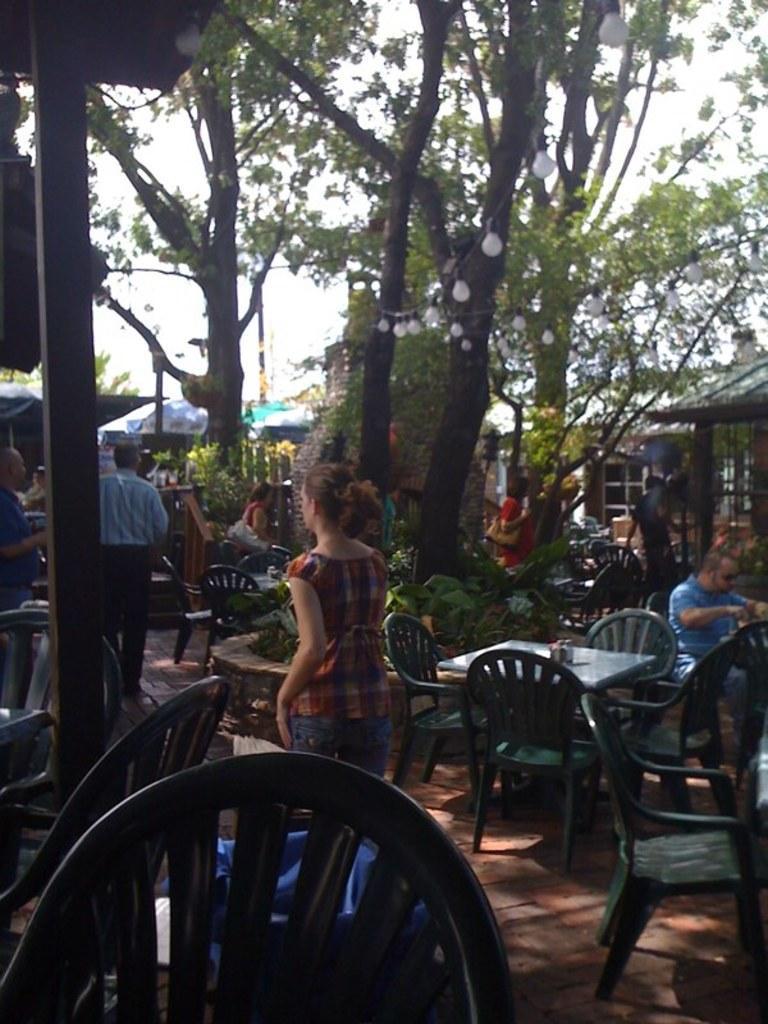How would you summarize this image in a sentence or two? On the background we can see trees and lights here. We can see few umbrellas. we can see few persons standing and there are lot many empty chairs and tables. We can see a man with blue shirt sitting on a chair at the right side of the picture. 